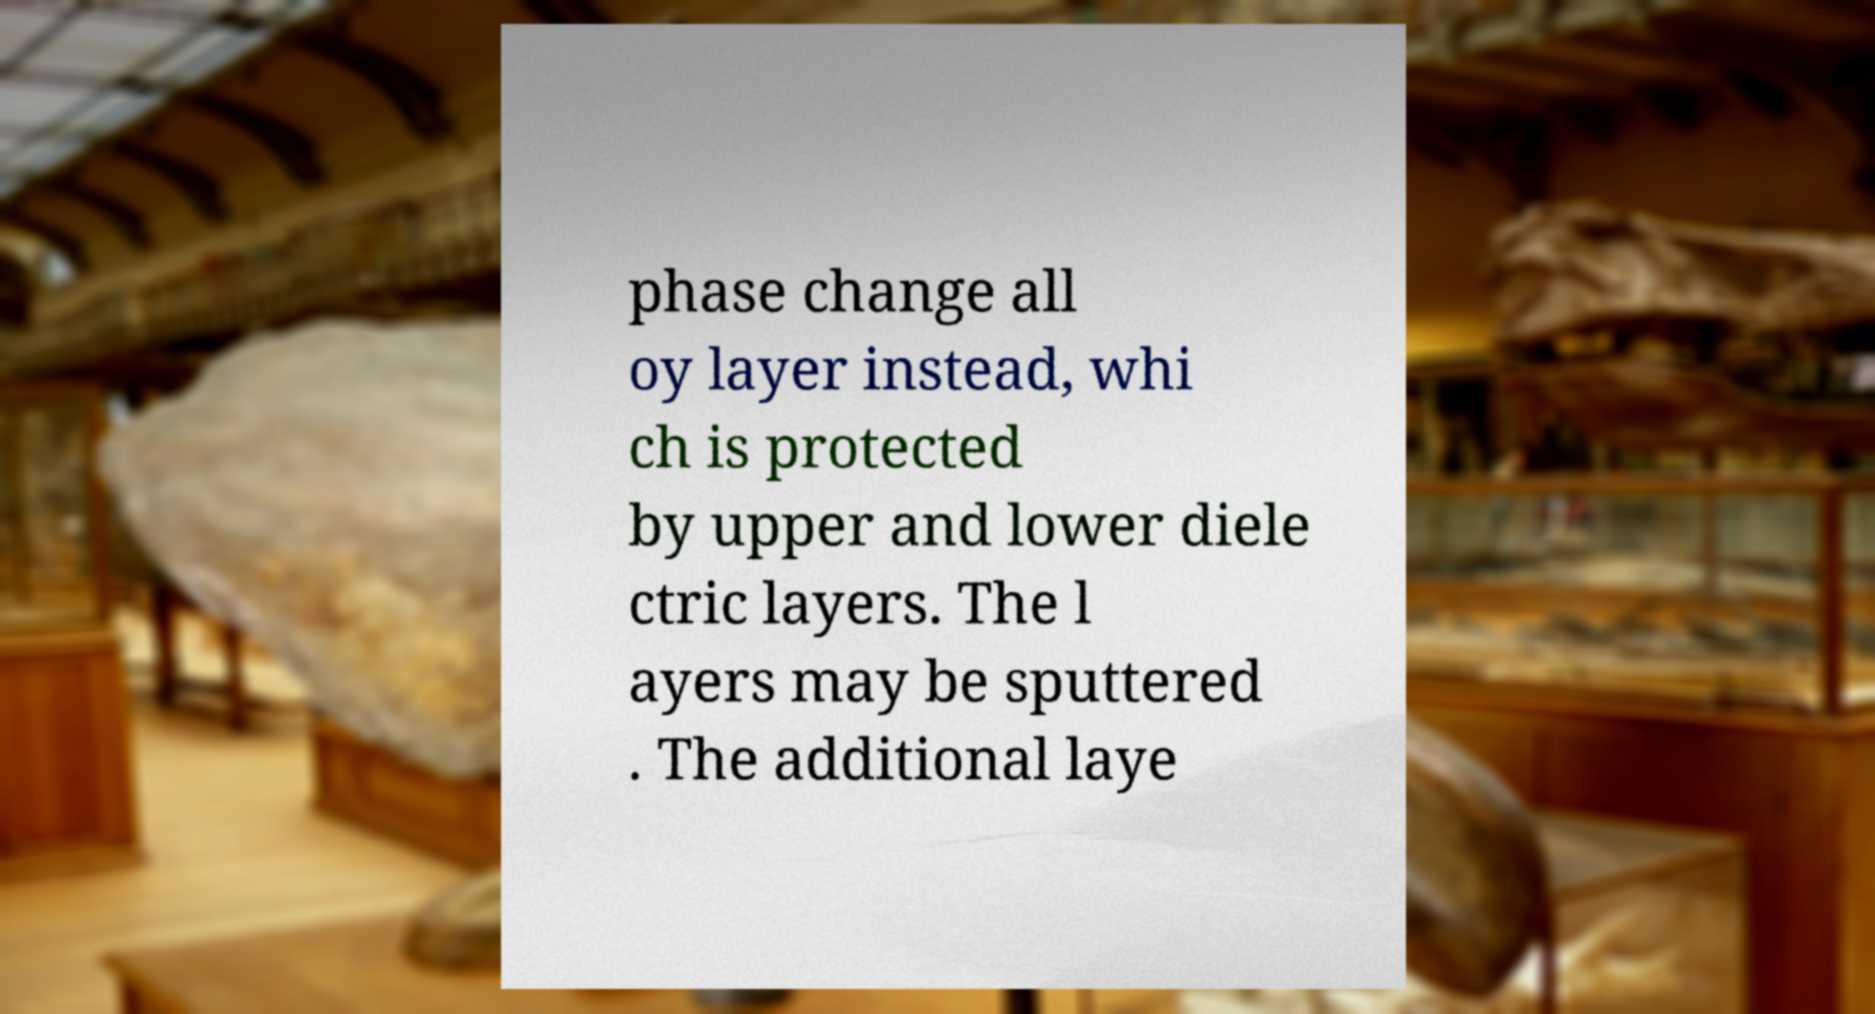There's text embedded in this image that I need extracted. Can you transcribe it verbatim? phase change all oy layer instead, whi ch is protected by upper and lower diele ctric layers. The l ayers may be sputtered . The additional laye 